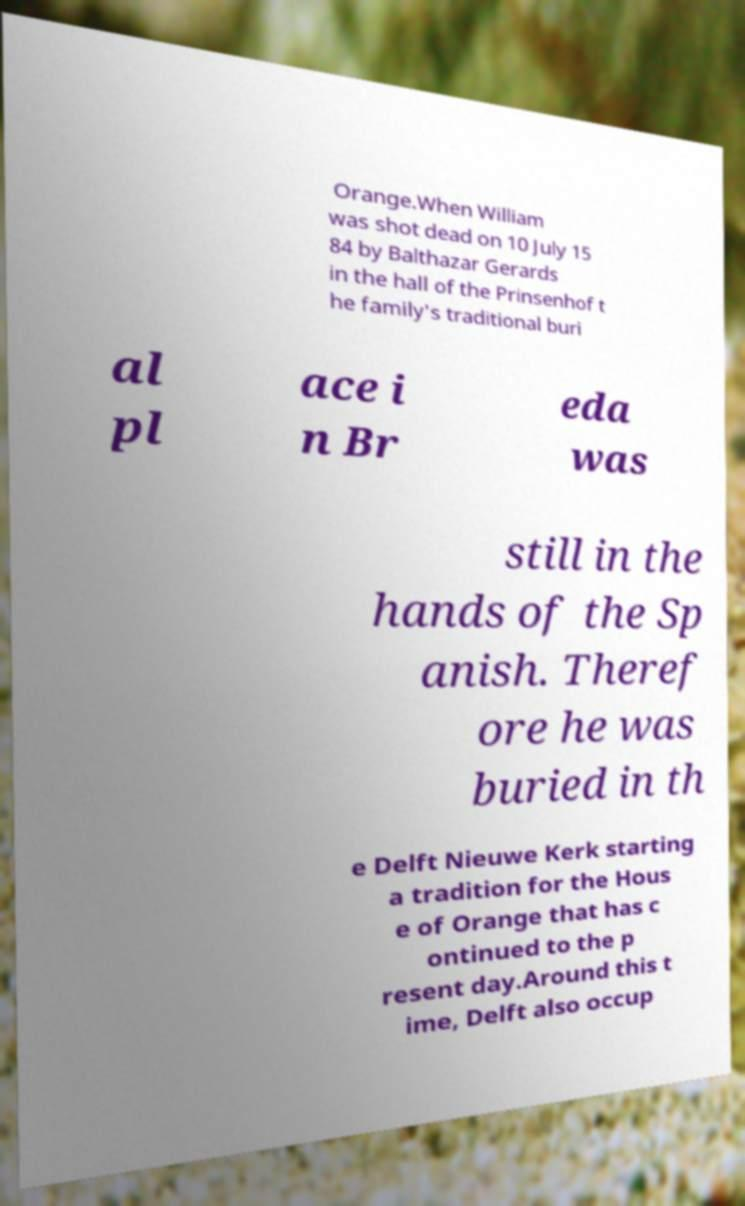For documentation purposes, I need the text within this image transcribed. Could you provide that? Orange.When William was shot dead on 10 July 15 84 by Balthazar Gerards in the hall of the Prinsenhof t he family's traditional buri al pl ace i n Br eda was still in the hands of the Sp anish. Theref ore he was buried in th e Delft Nieuwe Kerk starting a tradition for the Hous e of Orange that has c ontinued to the p resent day.Around this t ime, Delft also occup 